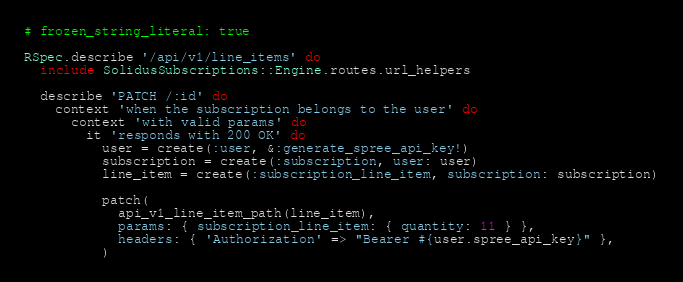<code> <loc_0><loc_0><loc_500><loc_500><_Ruby_># frozen_string_literal: true

RSpec.describe '/api/v1/line_items' do
  include SolidusSubscriptions::Engine.routes.url_helpers

  describe 'PATCH /:id' do
    context 'when the subscription belongs to the user' do
      context 'with valid params' do
        it 'responds with 200 OK' do
          user = create(:user, &:generate_spree_api_key!)
          subscription = create(:subscription, user: user)
          line_item = create(:subscription_line_item, subscription: subscription)

          patch(
            api_v1_line_item_path(line_item),
            params: { subscription_line_item: { quantity: 11 } },
            headers: { 'Authorization' => "Bearer #{user.spree_api_key}" },
          )
</code> 